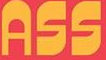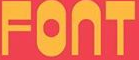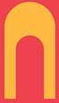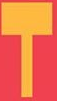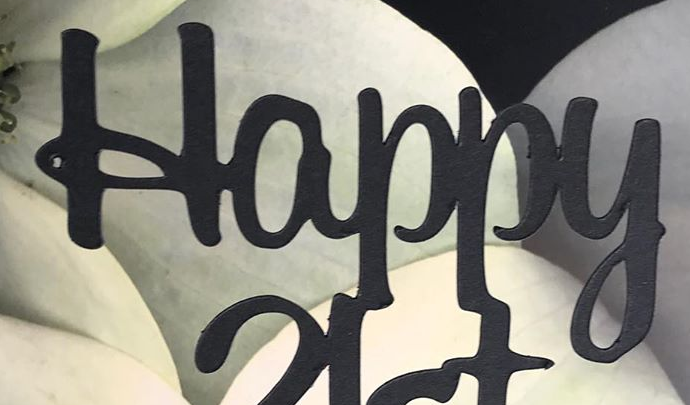What text is displayed in these images sequentially, separated by a semicolon? ASS; FONT; N; T; Happy 